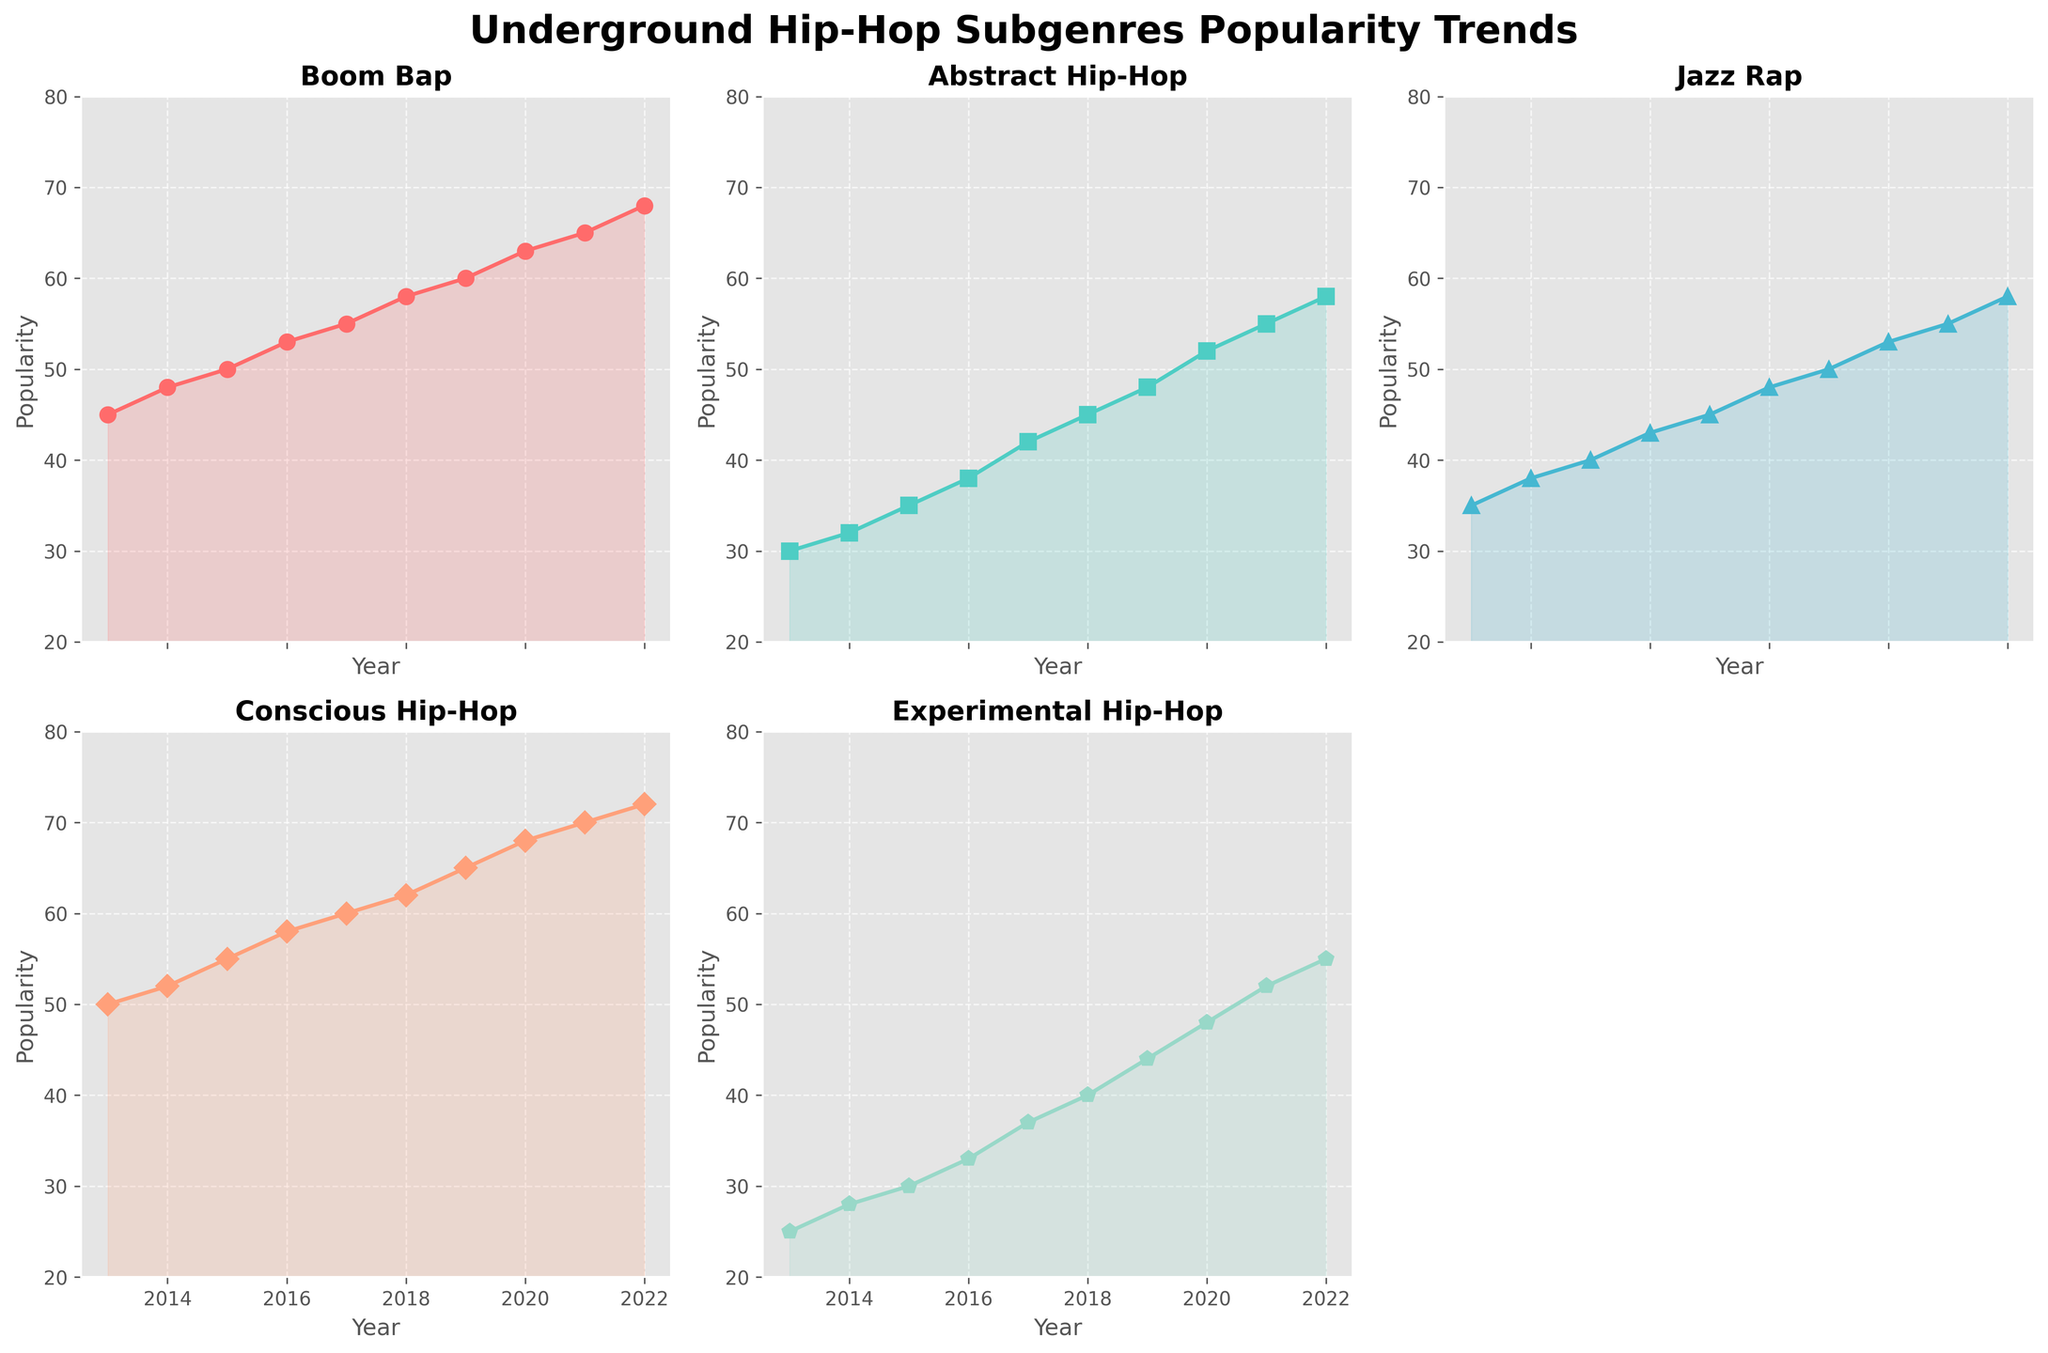What is the title of the figure? The title is located at the top of the figure and reads "Underground Hip-Hop Subgenres Popularity Trends."
Answer: Underground Hip-Hop Subgenres Popularity Trends How many subplots are shown in the figure? There are a total of 6 positions for subplots, out of which 5 are used, as indicated by the layout of the figure with one subplot left empty.
Answer: 5 Which subgenre shows the most significant increase in popularity from 2013 to 2022? By analyzing the rise in the data from 2013 to 2022 for each subgenre, Conscious Hip-Hop shows the most significant increase, starting at 50 and ending at 72.
Answer: Conscious Hip-Hop Which subgenre had the lowest popularity in 2013? By examining the values for each subgenre in 2013, Experimental Hip-Hop had the lowest popularity with a value of 25.
Answer: Experimental Hip-Hop Compare the popularity of Jazz Rap and Abstract Hip-Hop in 2020. Which one was more popular and by how many points? In 2020, Jazz Rap had a popularity of 53, and Abstract Hip-Hop had a popularity of 52. Jazz Rap was more popular by 1 point.
Answer: Jazz Rap, by 1 point What is the average popularity of Boom Bap from 2013 to 2022? The values for Boom Bap are [45, 48, 50, 53, 55, 58, 60, 63, 65, 68]. Summing these values gives 565, and dividing by the number of years (10) gives 56.5.
Answer: 56.5 During which year did Experimental Hip-Hop cross the 40-point popularity mark? By looking at the subplot for Experimental Hip-Hop, the year when it crossed the 40-point mark is 2020.
Answer: 2020 Which subgenre had the most stable popularity trend over the decade? By observing the trend lines for each subgenre, Abstract Hip-Hop has the most stable and gradual trend with fewer fluctuations.
Answer: Abstract Hip-Hop What is the difference in popularity between Boom Bap and Conscious Hip-Hop in 2017? In 2017, Boom Bap had a popularity of 55, while Conscious Hip-Hop had a popularity of 60. The difference is 5 points.
Answer: 5 points Which subgenre saw the biggest single-year increase in popularity, and in which year? By analyzing the steepest slope between two consecutive years for all subgenres, Conscious Hip-Hop saw the biggest single-year increase (8 points) from 2019 to 2020.
Answer: Conscious Hip-Hop, 2019 to 2020 